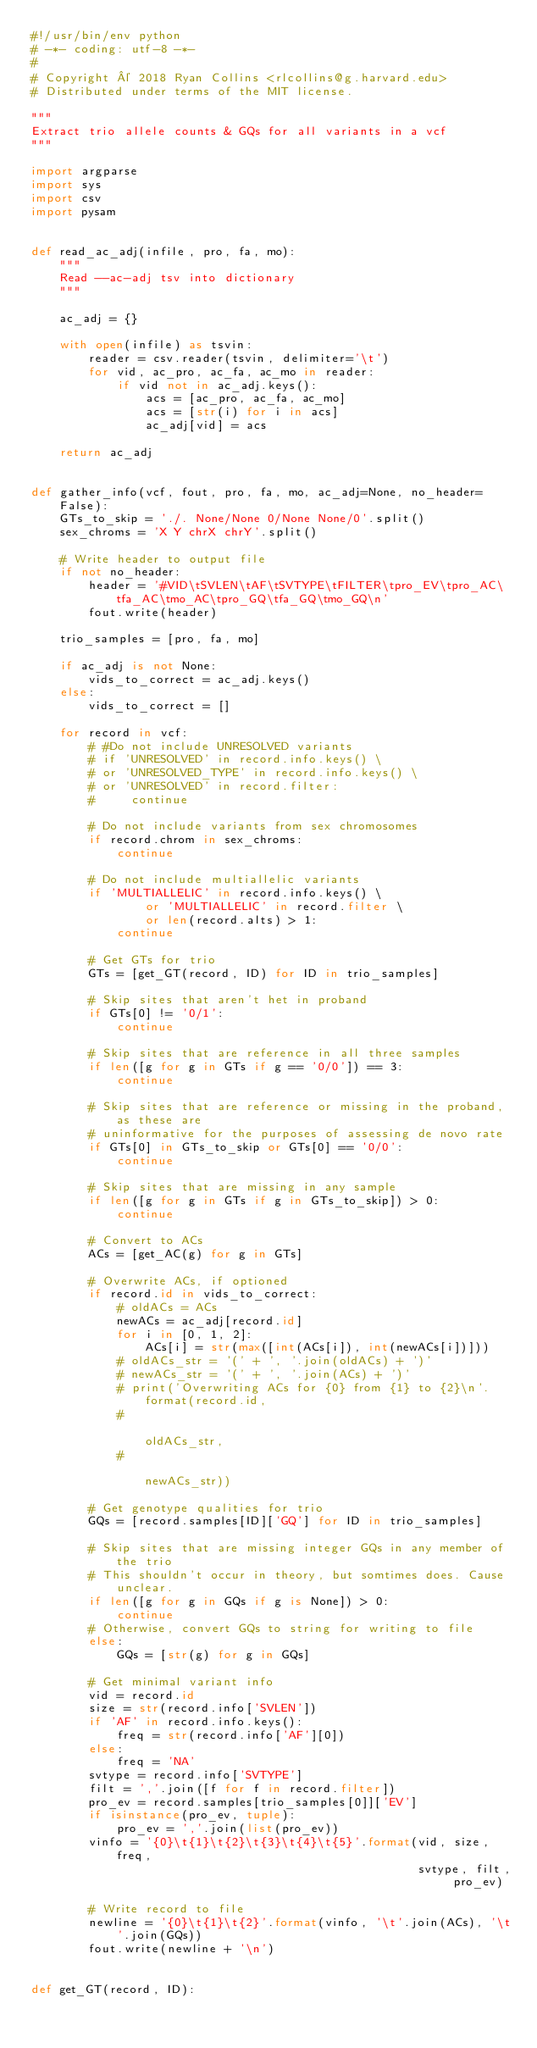<code> <loc_0><loc_0><loc_500><loc_500><_Python_>#!/usr/bin/env python
# -*- coding: utf-8 -*-
#
# Copyright © 2018 Ryan Collins <rlcollins@g.harvard.edu>
# Distributed under terms of the MIT license.

"""
Extract trio allele counts & GQs for all variants in a vcf
"""

import argparse
import sys
import csv
import pysam


def read_ac_adj(infile, pro, fa, mo):
    """
    Read --ac-adj tsv into dictionary
    """

    ac_adj = {}

    with open(infile) as tsvin:
        reader = csv.reader(tsvin, delimiter='\t')
        for vid, ac_pro, ac_fa, ac_mo in reader:
            if vid not in ac_adj.keys():
                acs = [ac_pro, ac_fa, ac_mo]
                acs = [str(i) for i in acs]
                ac_adj[vid] = acs

    return ac_adj


def gather_info(vcf, fout, pro, fa, mo, ac_adj=None, no_header=False):
    GTs_to_skip = './. None/None 0/None None/0'.split()
    sex_chroms = 'X Y chrX chrY'.split()

    # Write header to output file
    if not no_header:
        header = '#VID\tSVLEN\tAF\tSVTYPE\tFILTER\tpro_EV\tpro_AC\tfa_AC\tmo_AC\tpro_GQ\tfa_GQ\tmo_GQ\n'
        fout.write(header)

    trio_samples = [pro, fa, mo]

    if ac_adj is not None:
        vids_to_correct = ac_adj.keys()
    else:
        vids_to_correct = []

    for record in vcf:
        # #Do not include UNRESOLVED variants
        # if 'UNRESOLVED' in record.info.keys() \
        # or 'UNRESOLVED_TYPE' in record.info.keys() \
        # or 'UNRESOLVED' in record.filter:
        #     continue

        # Do not include variants from sex chromosomes
        if record.chrom in sex_chroms:
            continue

        # Do not include multiallelic variants
        if 'MULTIALLELIC' in record.info.keys() \
                or 'MULTIALLELIC' in record.filter \
                or len(record.alts) > 1:
            continue

        # Get GTs for trio
        GTs = [get_GT(record, ID) for ID in trio_samples]

        # Skip sites that aren't het in proband
        if GTs[0] != '0/1':
            continue

        # Skip sites that are reference in all three samples
        if len([g for g in GTs if g == '0/0']) == 3:
            continue

        # Skip sites that are reference or missing in the proband, as these are
        # uninformative for the purposes of assessing de novo rate
        if GTs[0] in GTs_to_skip or GTs[0] == '0/0':
            continue

        # Skip sites that are missing in any sample
        if len([g for g in GTs if g in GTs_to_skip]) > 0:
            continue

        # Convert to ACs
        ACs = [get_AC(g) for g in GTs]

        # Overwrite ACs, if optioned
        if record.id in vids_to_correct:
            # oldACs = ACs
            newACs = ac_adj[record.id]
            for i in [0, 1, 2]:
                ACs[i] = str(max([int(ACs[i]), int(newACs[i])]))
            # oldACs_str = '(' + ', '.join(oldACs) + ')'
            # newACs_str = '(' + ', '.join(ACs) + ')'
            # print('Overwriting ACs for {0} from {1} to {2}\n'.format(record.id,
            #                                                          oldACs_str,
            #                                                          newACs_str))

        # Get genotype qualities for trio
        GQs = [record.samples[ID]['GQ'] for ID in trio_samples]

        # Skip sites that are missing integer GQs in any member of the trio
        # This shouldn't occur in theory, but somtimes does. Cause unclear.
        if len([g for g in GQs if g is None]) > 0:
            continue
        # Otherwise, convert GQs to string for writing to file
        else:
            GQs = [str(g) for g in GQs]

        # Get minimal variant info
        vid = record.id
        size = str(record.info['SVLEN'])
        if 'AF' in record.info.keys():
            freq = str(record.info['AF'][0])
        else:
            freq = 'NA'
        svtype = record.info['SVTYPE']
        filt = ','.join([f for f in record.filter])
        pro_ev = record.samples[trio_samples[0]]['EV']
        if isinstance(pro_ev, tuple):
            pro_ev = ','.join(list(pro_ev))
        vinfo = '{0}\t{1}\t{2}\t{3}\t{4}\t{5}'.format(vid, size, freq,
                                                      svtype, filt, pro_ev)

        # Write record to file
        newline = '{0}\t{1}\t{2}'.format(vinfo, '\t'.join(ACs), '\t'.join(GQs))
        fout.write(newline + '\n')


def get_GT(record, ID):</code> 